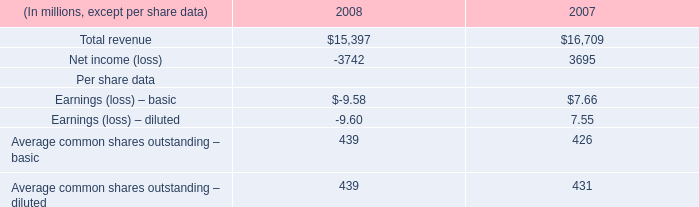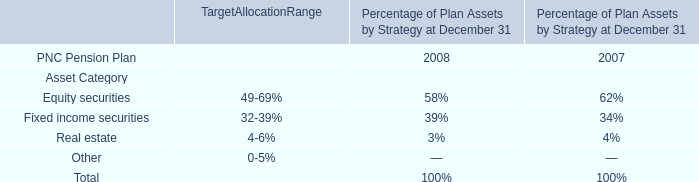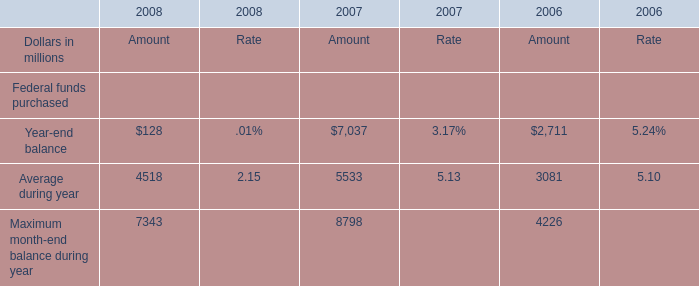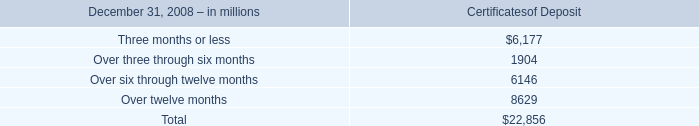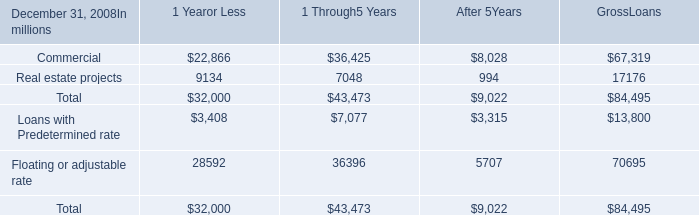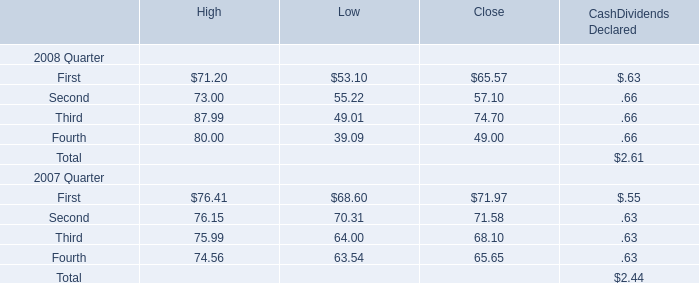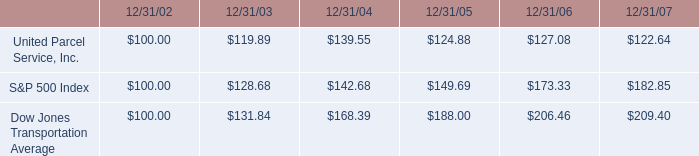What is the sum of elements in 2008 ? (in million) 
Computations: (((6177 + 1904) + 6146) + 8629)
Answer: 22856.0. 